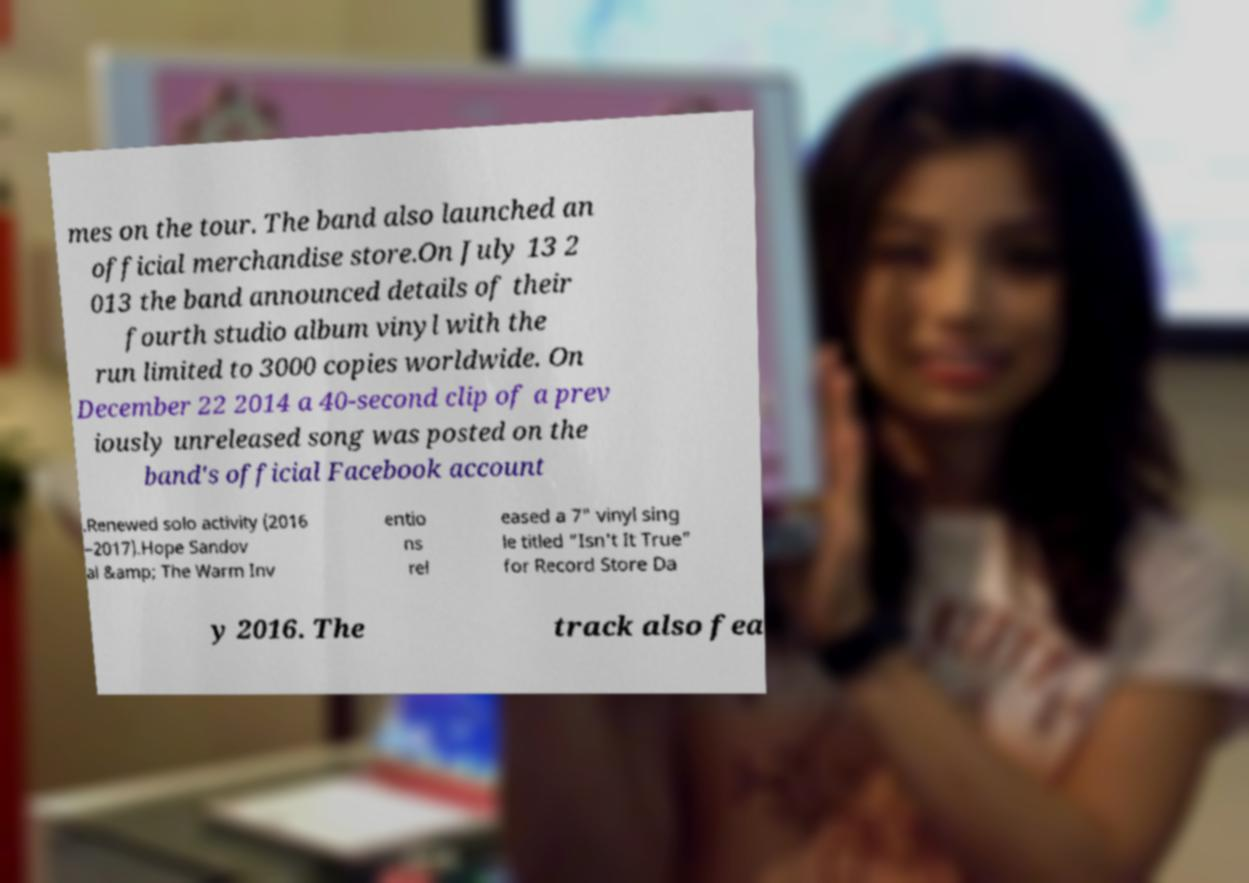For documentation purposes, I need the text within this image transcribed. Could you provide that? mes on the tour. The band also launched an official merchandise store.On July 13 2 013 the band announced details of their fourth studio album vinyl with the run limited to 3000 copies worldwide. On December 22 2014 a 40-second clip of a prev iously unreleased song was posted on the band's official Facebook account .Renewed solo activity (2016 –2017).Hope Sandov al &amp; The Warm Inv entio ns rel eased a 7" vinyl sing le titled "Isn't It True" for Record Store Da y 2016. The track also fea 